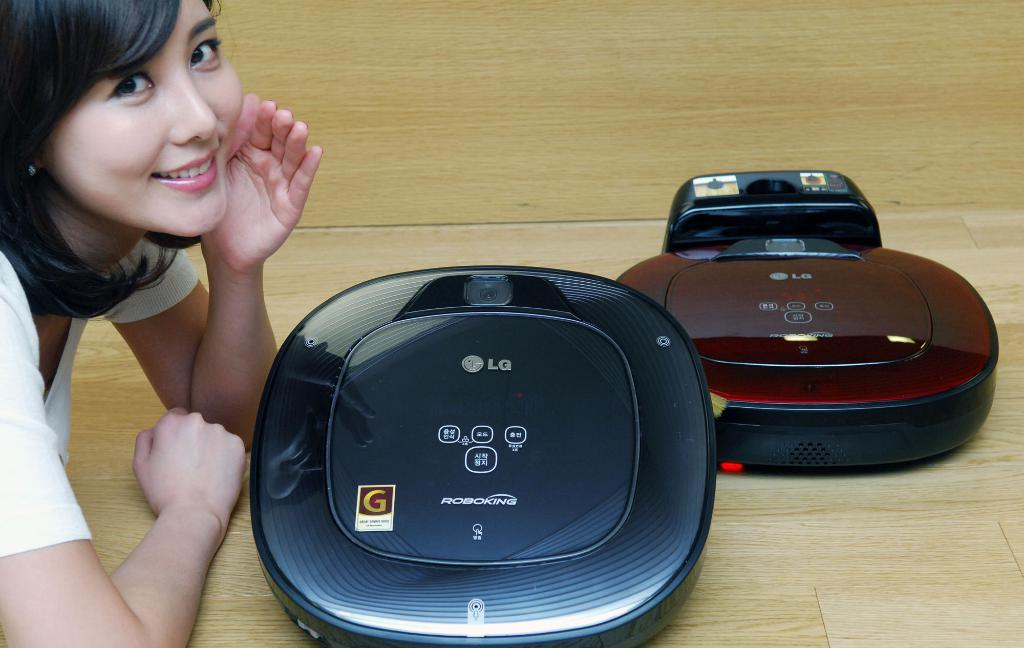<image>
Summarize the visual content of the image. A woman showing off two CD players by LG. 